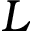Convert formula to latex. <formula><loc_0><loc_0><loc_500><loc_500>L</formula> 